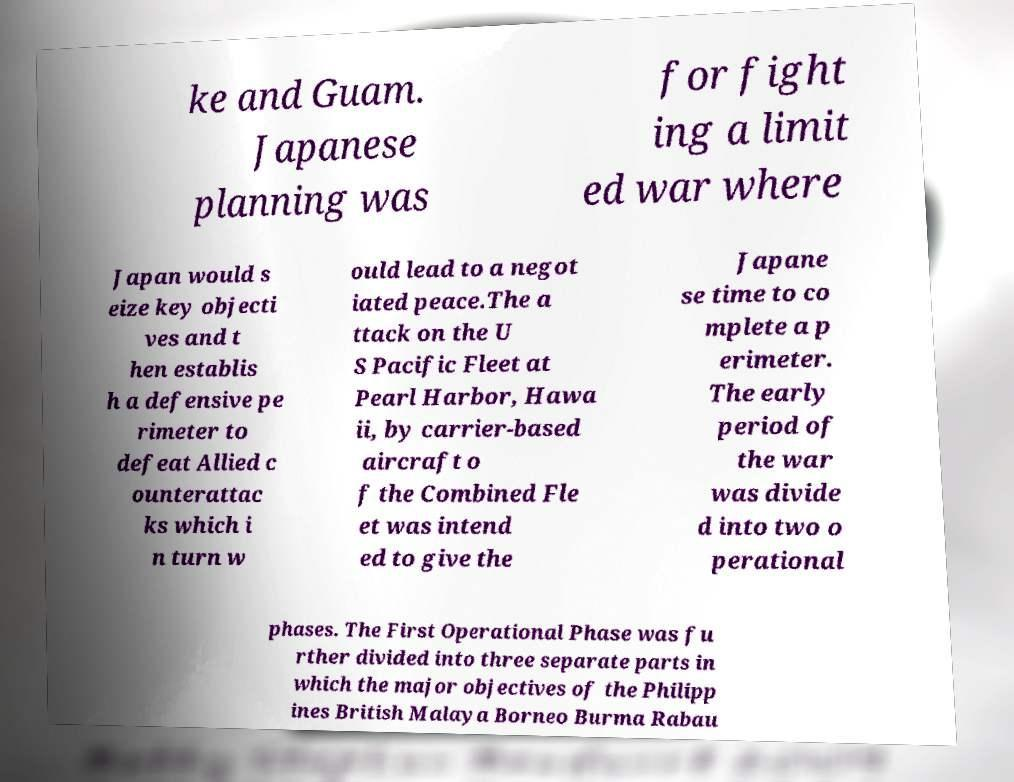For documentation purposes, I need the text within this image transcribed. Could you provide that? ke and Guam. Japanese planning was for fight ing a limit ed war where Japan would s eize key objecti ves and t hen establis h a defensive pe rimeter to defeat Allied c ounterattac ks which i n turn w ould lead to a negot iated peace.The a ttack on the U S Pacific Fleet at Pearl Harbor, Hawa ii, by carrier-based aircraft o f the Combined Fle et was intend ed to give the Japane se time to co mplete a p erimeter. The early period of the war was divide d into two o perational phases. The First Operational Phase was fu rther divided into three separate parts in which the major objectives of the Philipp ines British Malaya Borneo Burma Rabau 